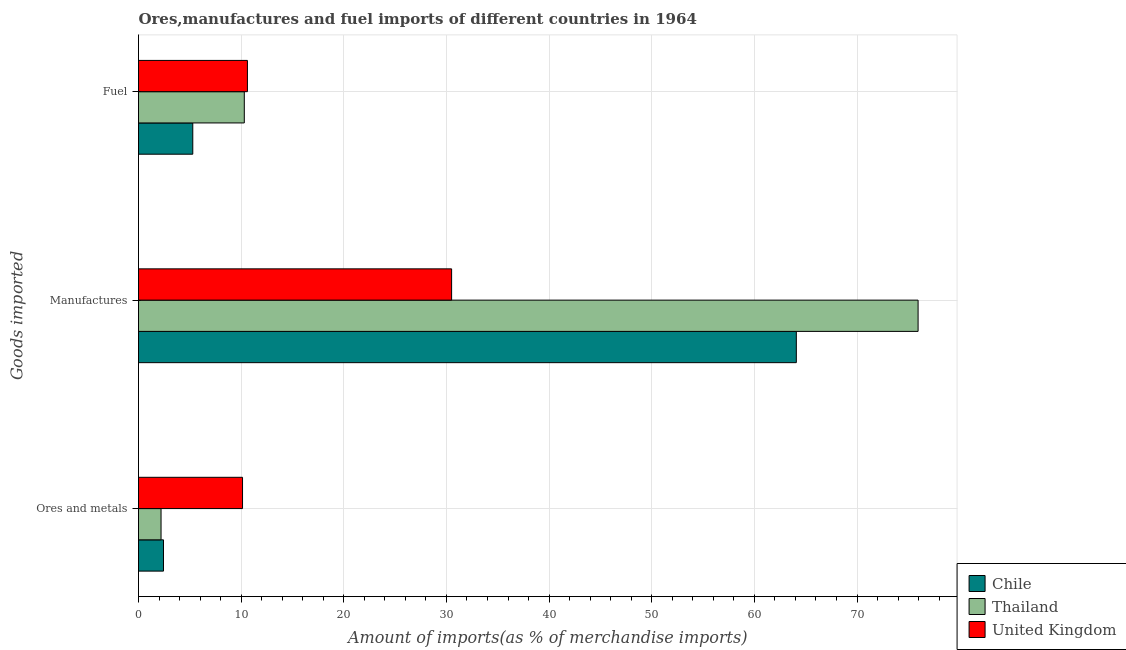How many different coloured bars are there?
Make the answer very short. 3. How many groups of bars are there?
Your response must be concise. 3. How many bars are there on the 2nd tick from the top?
Give a very brief answer. 3. How many bars are there on the 3rd tick from the bottom?
Your answer should be compact. 3. What is the label of the 2nd group of bars from the top?
Ensure brevity in your answer.  Manufactures. What is the percentage of ores and metals imports in United Kingdom?
Ensure brevity in your answer.  10.13. Across all countries, what is the maximum percentage of ores and metals imports?
Keep it short and to the point. 10.13. Across all countries, what is the minimum percentage of manufactures imports?
Ensure brevity in your answer.  30.5. What is the total percentage of manufactures imports in the graph?
Your answer should be very brief. 170.54. What is the difference between the percentage of manufactures imports in United Kingdom and that in Thailand?
Provide a short and direct response. -45.45. What is the difference between the percentage of fuel imports in Chile and the percentage of ores and metals imports in Thailand?
Provide a short and direct response. 3.09. What is the average percentage of ores and metals imports per country?
Your answer should be very brief. 4.92. What is the difference between the percentage of ores and metals imports and percentage of manufactures imports in Chile?
Your response must be concise. -61.65. What is the ratio of the percentage of manufactures imports in Thailand to that in United Kingdom?
Your response must be concise. 2.49. Is the percentage of manufactures imports in Thailand less than that in Chile?
Your answer should be very brief. No. Is the difference between the percentage of manufactures imports in Chile and United Kingdom greater than the difference between the percentage of ores and metals imports in Chile and United Kingdom?
Ensure brevity in your answer.  Yes. What is the difference between the highest and the second highest percentage of manufactures imports?
Provide a succinct answer. 11.86. What is the difference between the highest and the lowest percentage of manufactures imports?
Give a very brief answer. 45.45. In how many countries, is the percentage of manufactures imports greater than the average percentage of manufactures imports taken over all countries?
Provide a short and direct response. 2. What does the 3rd bar from the top in Ores and metals represents?
Your response must be concise. Chile. What does the 1st bar from the bottom in Fuel represents?
Make the answer very short. Chile. Is it the case that in every country, the sum of the percentage of ores and metals imports and percentage of manufactures imports is greater than the percentage of fuel imports?
Provide a succinct answer. Yes. How many bars are there?
Ensure brevity in your answer.  9. Are all the bars in the graph horizontal?
Provide a succinct answer. Yes. What is the difference between two consecutive major ticks on the X-axis?
Offer a very short reply. 10. What is the title of the graph?
Offer a terse response. Ores,manufactures and fuel imports of different countries in 1964. Does "Ireland" appear as one of the legend labels in the graph?
Provide a succinct answer. No. What is the label or title of the X-axis?
Your answer should be compact. Amount of imports(as % of merchandise imports). What is the label or title of the Y-axis?
Make the answer very short. Goods imported. What is the Amount of imports(as % of merchandise imports) in Chile in Ores and metals?
Offer a very short reply. 2.43. What is the Amount of imports(as % of merchandise imports) of Thailand in Ores and metals?
Provide a succinct answer. 2.2. What is the Amount of imports(as % of merchandise imports) in United Kingdom in Ores and metals?
Keep it short and to the point. 10.13. What is the Amount of imports(as % of merchandise imports) of Chile in Manufactures?
Give a very brief answer. 64.09. What is the Amount of imports(as % of merchandise imports) of Thailand in Manufactures?
Offer a terse response. 75.95. What is the Amount of imports(as % of merchandise imports) of United Kingdom in Manufactures?
Make the answer very short. 30.5. What is the Amount of imports(as % of merchandise imports) of Chile in Fuel?
Ensure brevity in your answer.  5.29. What is the Amount of imports(as % of merchandise imports) in Thailand in Fuel?
Your answer should be very brief. 10.31. What is the Amount of imports(as % of merchandise imports) in United Kingdom in Fuel?
Provide a short and direct response. 10.61. Across all Goods imported, what is the maximum Amount of imports(as % of merchandise imports) in Chile?
Ensure brevity in your answer.  64.09. Across all Goods imported, what is the maximum Amount of imports(as % of merchandise imports) in Thailand?
Keep it short and to the point. 75.95. Across all Goods imported, what is the maximum Amount of imports(as % of merchandise imports) in United Kingdom?
Give a very brief answer. 30.5. Across all Goods imported, what is the minimum Amount of imports(as % of merchandise imports) in Chile?
Give a very brief answer. 2.43. Across all Goods imported, what is the minimum Amount of imports(as % of merchandise imports) in Thailand?
Make the answer very short. 2.2. Across all Goods imported, what is the minimum Amount of imports(as % of merchandise imports) in United Kingdom?
Ensure brevity in your answer.  10.13. What is the total Amount of imports(as % of merchandise imports) of Chile in the graph?
Offer a terse response. 71.81. What is the total Amount of imports(as % of merchandise imports) of Thailand in the graph?
Your answer should be very brief. 88.45. What is the total Amount of imports(as % of merchandise imports) of United Kingdom in the graph?
Your response must be concise. 51.25. What is the difference between the Amount of imports(as % of merchandise imports) in Chile in Ores and metals and that in Manufactures?
Offer a terse response. -61.65. What is the difference between the Amount of imports(as % of merchandise imports) in Thailand in Ores and metals and that in Manufactures?
Provide a succinct answer. -73.75. What is the difference between the Amount of imports(as % of merchandise imports) in United Kingdom in Ores and metals and that in Manufactures?
Your answer should be very brief. -20.37. What is the difference between the Amount of imports(as % of merchandise imports) in Chile in Ores and metals and that in Fuel?
Offer a terse response. -2.85. What is the difference between the Amount of imports(as % of merchandise imports) in Thailand in Ores and metals and that in Fuel?
Offer a very short reply. -8.11. What is the difference between the Amount of imports(as % of merchandise imports) of United Kingdom in Ores and metals and that in Fuel?
Your answer should be very brief. -0.48. What is the difference between the Amount of imports(as % of merchandise imports) of Chile in Manufactures and that in Fuel?
Your answer should be compact. 58.8. What is the difference between the Amount of imports(as % of merchandise imports) in Thailand in Manufactures and that in Fuel?
Offer a terse response. 65.64. What is the difference between the Amount of imports(as % of merchandise imports) in United Kingdom in Manufactures and that in Fuel?
Give a very brief answer. 19.89. What is the difference between the Amount of imports(as % of merchandise imports) of Chile in Ores and metals and the Amount of imports(as % of merchandise imports) of Thailand in Manufactures?
Provide a succinct answer. -73.52. What is the difference between the Amount of imports(as % of merchandise imports) of Chile in Ores and metals and the Amount of imports(as % of merchandise imports) of United Kingdom in Manufactures?
Ensure brevity in your answer.  -28.07. What is the difference between the Amount of imports(as % of merchandise imports) of Thailand in Ores and metals and the Amount of imports(as % of merchandise imports) of United Kingdom in Manufactures?
Offer a terse response. -28.31. What is the difference between the Amount of imports(as % of merchandise imports) of Chile in Ores and metals and the Amount of imports(as % of merchandise imports) of Thailand in Fuel?
Your answer should be very brief. -7.87. What is the difference between the Amount of imports(as % of merchandise imports) in Chile in Ores and metals and the Amount of imports(as % of merchandise imports) in United Kingdom in Fuel?
Your answer should be compact. -8.18. What is the difference between the Amount of imports(as % of merchandise imports) in Thailand in Ores and metals and the Amount of imports(as % of merchandise imports) in United Kingdom in Fuel?
Provide a succinct answer. -8.41. What is the difference between the Amount of imports(as % of merchandise imports) of Chile in Manufactures and the Amount of imports(as % of merchandise imports) of Thailand in Fuel?
Offer a terse response. 53.78. What is the difference between the Amount of imports(as % of merchandise imports) in Chile in Manufactures and the Amount of imports(as % of merchandise imports) in United Kingdom in Fuel?
Your answer should be very brief. 53.48. What is the difference between the Amount of imports(as % of merchandise imports) in Thailand in Manufactures and the Amount of imports(as % of merchandise imports) in United Kingdom in Fuel?
Make the answer very short. 65.34. What is the average Amount of imports(as % of merchandise imports) in Chile per Goods imported?
Provide a succinct answer. 23.94. What is the average Amount of imports(as % of merchandise imports) in Thailand per Goods imported?
Offer a very short reply. 29.48. What is the average Amount of imports(as % of merchandise imports) in United Kingdom per Goods imported?
Keep it short and to the point. 17.08. What is the difference between the Amount of imports(as % of merchandise imports) in Chile and Amount of imports(as % of merchandise imports) in Thailand in Ores and metals?
Your response must be concise. 0.24. What is the difference between the Amount of imports(as % of merchandise imports) in Chile and Amount of imports(as % of merchandise imports) in United Kingdom in Ores and metals?
Your answer should be compact. -7.7. What is the difference between the Amount of imports(as % of merchandise imports) in Thailand and Amount of imports(as % of merchandise imports) in United Kingdom in Ores and metals?
Offer a very short reply. -7.94. What is the difference between the Amount of imports(as % of merchandise imports) of Chile and Amount of imports(as % of merchandise imports) of Thailand in Manufactures?
Your answer should be very brief. -11.86. What is the difference between the Amount of imports(as % of merchandise imports) of Chile and Amount of imports(as % of merchandise imports) of United Kingdom in Manufactures?
Offer a terse response. 33.58. What is the difference between the Amount of imports(as % of merchandise imports) of Thailand and Amount of imports(as % of merchandise imports) of United Kingdom in Manufactures?
Give a very brief answer. 45.45. What is the difference between the Amount of imports(as % of merchandise imports) of Chile and Amount of imports(as % of merchandise imports) of Thailand in Fuel?
Give a very brief answer. -5.02. What is the difference between the Amount of imports(as % of merchandise imports) of Chile and Amount of imports(as % of merchandise imports) of United Kingdom in Fuel?
Provide a succinct answer. -5.32. What is the difference between the Amount of imports(as % of merchandise imports) of Thailand and Amount of imports(as % of merchandise imports) of United Kingdom in Fuel?
Offer a very short reply. -0.3. What is the ratio of the Amount of imports(as % of merchandise imports) in Chile in Ores and metals to that in Manufactures?
Your answer should be very brief. 0.04. What is the ratio of the Amount of imports(as % of merchandise imports) in Thailand in Ores and metals to that in Manufactures?
Provide a succinct answer. 0.03. What is the ratio of the Amount of imports(as % of merchandise imports) of United Kingdom in Ores and metals to that in Manufactures?
Offer a terse response. 0.33. What is the ratio of the Amount of imports(as % of merchandise imports) in Chile in Ores and metals to that in Fuel?
Give a very brief answer. 0.46. What is the ratio of the Amount of imports(as % of merchandise imports) of Thailand in Ores and metals to that in Fuel?
Offer a very short reply. 0.21. What is the ratio of the Amount of imports(as % of merchandise imports) in United Kingdom in Ores and metals to that in Fuel?
Your answer should be very brief. 0.96. What is the ratio of the Amount of imports(as % of merchandise imports) in Chile in Manufactures to that in Fuel?
Provide a short and direct response. 12.12. What is the ratio of the Amount of imports(as % of merchandise imports) in Thailand in Manufactures to that in Fuel?
Your answer should be very brief. 7.37. What is the ratio of the Amount of imports(as % of merchandise imports) of United Kingdom in Manufactures to that in Fuel?
Your answer should be very brief. 2.87. What is the difference between the highest and the second highest Amount of imports(as % of merchandise imports) in Chile?
Keep it short and to the point. 58.8. What is the difference between the highest and the second highest Amount of imports(as % of merchandise imports) of Thailand?
Your answer should be compact. 65.64. What is the difference between the highest and the second highest Amount of imports(as % of merchandise imports) of United Kingdom?
Ensure brevity in your answer.  19.89. What is the difference between the highest and the lowest Amount of imports(as % of merchandise imports) in Chile?
Provide a succinct answer. 61.65. What is the difference between the highest and the lowest Amount of imports(as % of merchandise imports) in Thailand?
Your response must be concise. 73.75. What is the difference between the highest and the lowest Amount of imports(as % of merchandise imports) in United Kingdom?
Your response must be concise. 20.37. 